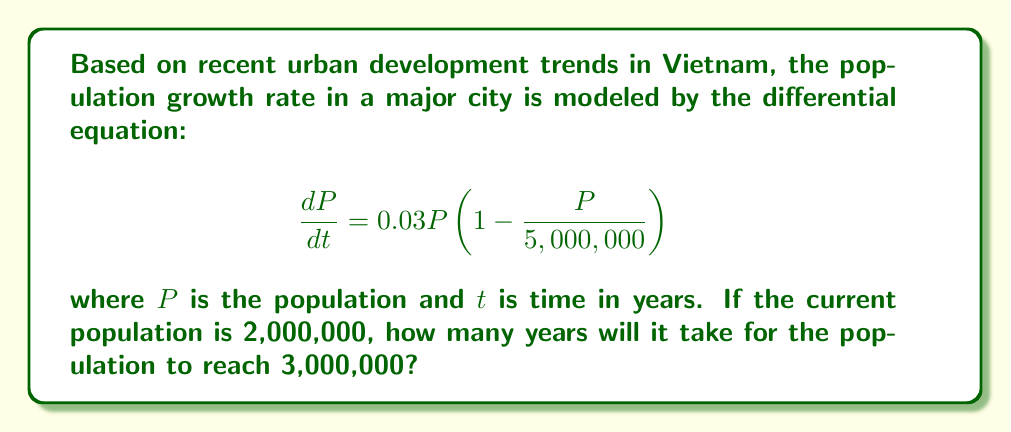What is the answer to this math problem? To solve this problem, we need to use the method of separation of variables and integration:

1) First, let's rearrange the differential equation:

   $$ \frac{dP}{P(1 - \frac{P}{5,000,000})} = 0.03dt $$

2) Integrate both sides:

   $$ \int \frac{dP}{P(1 - \frac{P}{5,000,000})} = \int 0.03dt $$

3) The left side can be integrated using partial fractions:

   $$ -\ln|P| + 5,000,000 \ln|5,000,000 - P| = 0.03t + C $$

4) Now, we need to use the initial condition. At $t=0$, $P=2,000,000$:

   $$ -\ln(2,000,000) + 5,000,000 \ln(3,000,000) = C $$

5) Subtract this from the general solution:

   $$ -\ln|P| + 5,000,000 \ln|5,000,000 - P| + \ln(2,000,000) - 5,000,000 \ln(3,000,000) = 0.03t $$

6) We want to find $t$ when $P = 3,000,000$. Substitute this:

   $$ -\ln(3,000,000) + 5,000,000 \ln(2,000,000) + \ln(2,000,000) - 5,000,000 \ln(3,000,000) = 0.03t $$

7) Solve for $t$:

   $$ t = \frac{-\ln(3,000,000) + 5,000,000 \ln(2,000,000) + \ln(2,000,000) - 5,000,000 \ln(3,000,000)}{0.03} $$

8) Calculate the value (you can use a calculator for this):

   $$ t \approx 16.77 $$

Therefore, it will take approximately 16.77 years for the population to reach 3,000,000.
Answer: Approximately 16.77 years 